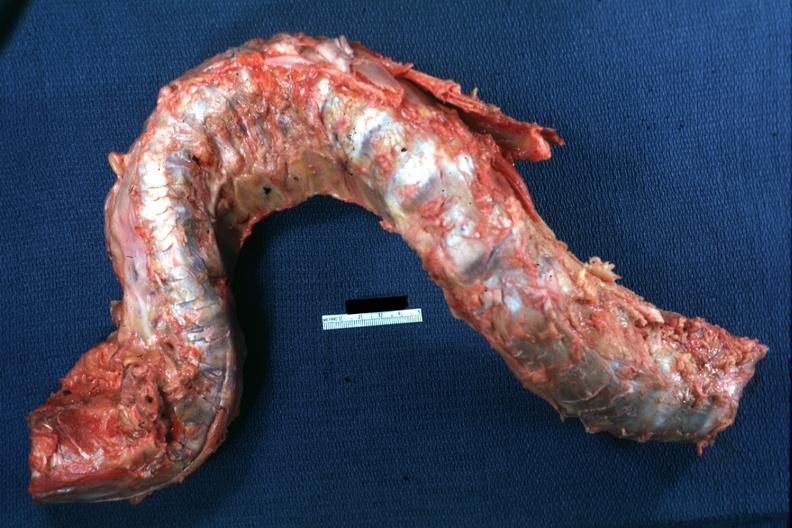what is present?
Answer the question using a single word or phrase. Joints 